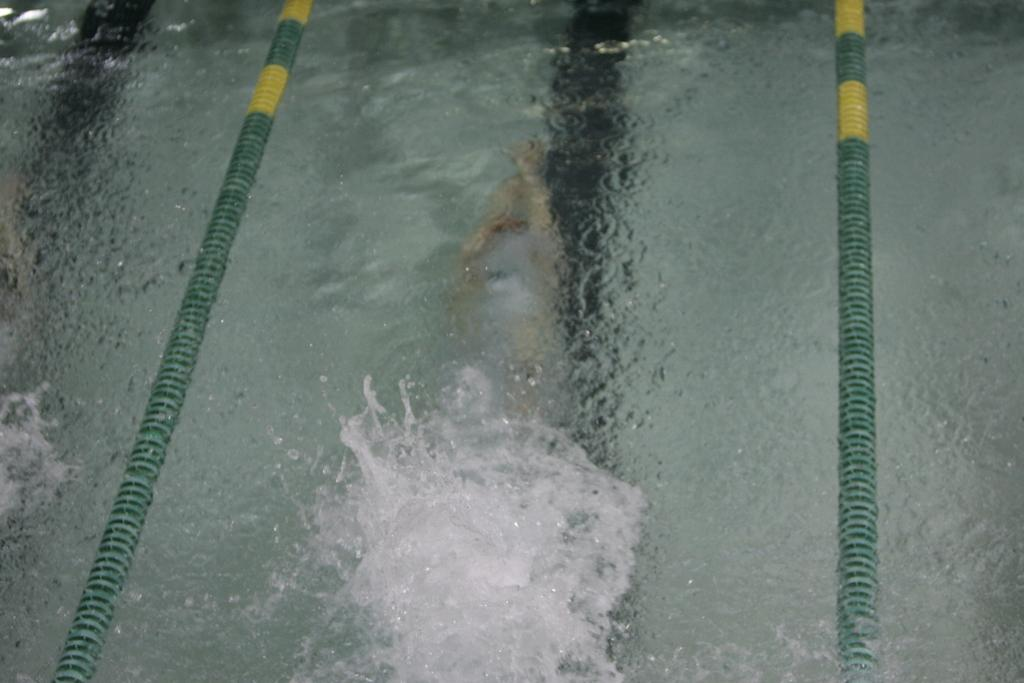What is the primary element in the image? There is water in the image. What activity is the person in the image engaged in? There is a person swimming in the water. Where is the mailbox located in the image? There is no mailbox present in the image, so there is no mailbox to be located. 